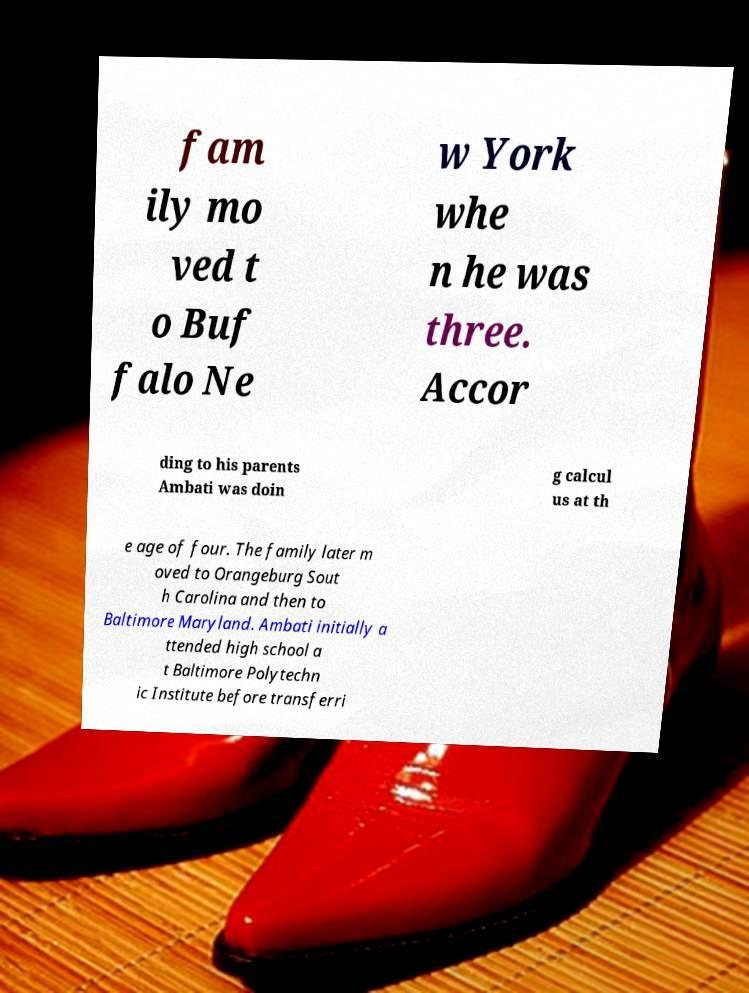Could you assist in decoding the text presented in this image and type it out clearly? fam ily mo ved t o Buf falo Ne w York whe n he was three. Accor ding to his parents Ambati was doin g calcul us at th e age of four. The family later m oved to Orangeburg Sout h Carolina and then to Baltimore Maryland. Ambati initially a ttended high school a t Baltimore Polytechn ic Institute before transferri 